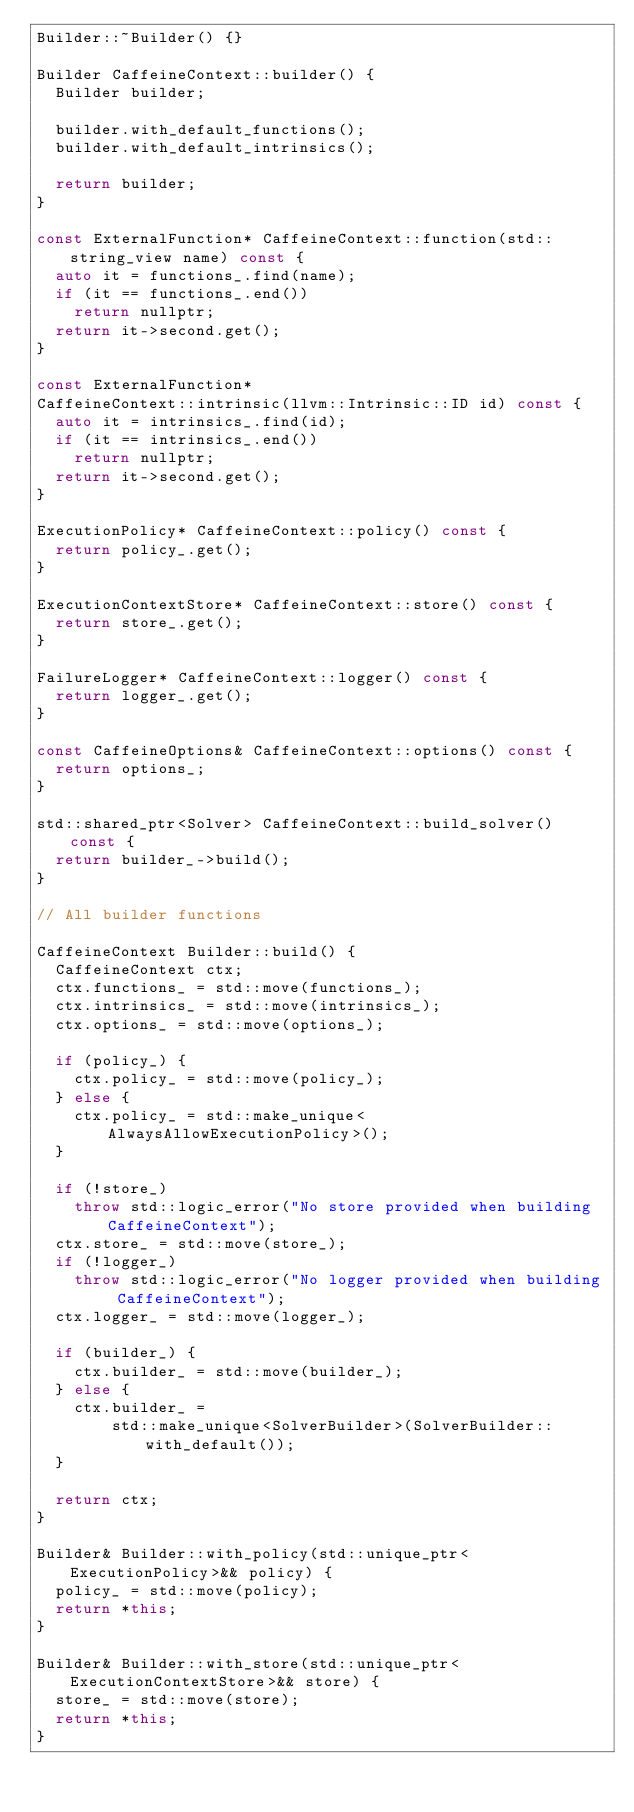Convert code to text. <code><loc_0><loc_0><loc_500><loc_500><_C++_>Builder::~Builder() {}

Builder CaffeineContext::builder() {
  Builder builder;

  builder.with_default_functions();
  builder.with_default_intrinsics();

  return builder;
}

const ExternalFunction* CaffeineContext::function(std::string_view name) const {
  auto it = functions_.find(name);
  if (it == functions_.end())
    return nullptr;
  return it->second.get();
}

const ExternalFunction*
CaffeineContext::intrinsic(llvm::Intrinsic::ID id) const {
  auto it = intrinsics_.find(id);
  if (it == intrinsics_.end())
    return nullptr;
  return it->second.get();
}

ExecutionPolicy* CaffeineContext::policy() const {
  return policy_.get();
}

ExecutionContextStore* CaffeineContext::store() const {
  return store_.get();
}

FailureLogger* CaffeineContext::logger() const {
  return logger_.get();
}

const CaffeineOptions& CaffeineContext::options() const {
  return options_;
}

std::shared_ptr<Solver> CaffeineContext::build_solver() const {
  return builder_->build();
}

// All builder functions

CaffeineContext Builder::build() {
  CaffeineContext ctx;
  ctx.functions_ = std::move(functions_);
  ctx.intrinsics_ = std::move(intrinsics_);
  ctx.options_ = std::move(options_);

  if (policy_) {
    ctx.policy_ = std::move(policy_);
  } else {
    ctx.policy_ = std::make_unique<AlwaysAllowExecutionPolicy>();
  }

  if (!store_)
    throw std::logic_error("No store provided when building CaffeineContext");
  ctx.store_ = std::move(store_);
  if (!logger_)
    throw std::logic_error("No logger provided when building CaffeineContext");
  ctx.logger_ = std::move(logger_);

  if (builder_) {
    ctx.builder_ = std::move(builder_);
  } else {
    ctx.builder_ =
        std::make_unique<SolverBuilder>(SolverBuilder::with_default());
  }

  return ctx;
}

Builder& Builder::with_policy(std::unique_ptr<ExecutionPolicy>&& policy) {
  policy_ = std::move(policy);
  return *this;
}

Builder& Builder::with_store(std::unique_ptr<ExecutionContextStore>&& store) {
  store_ = std::move(store);
  return *this;
}
</code> 